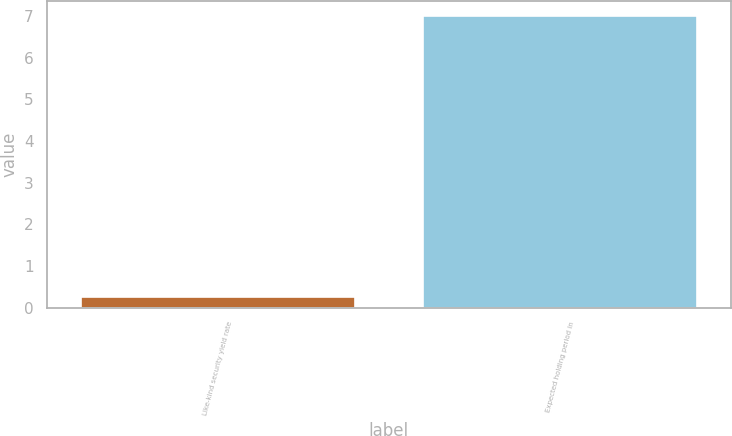Convert chart. <chart><loc_0><loc_0><loc_500><loc_500><bar_chart><fcel>Like-kind security yield rate<fcel>Expected holding period in<nl><fcel>0.27<fcel>7<nl></chart> 